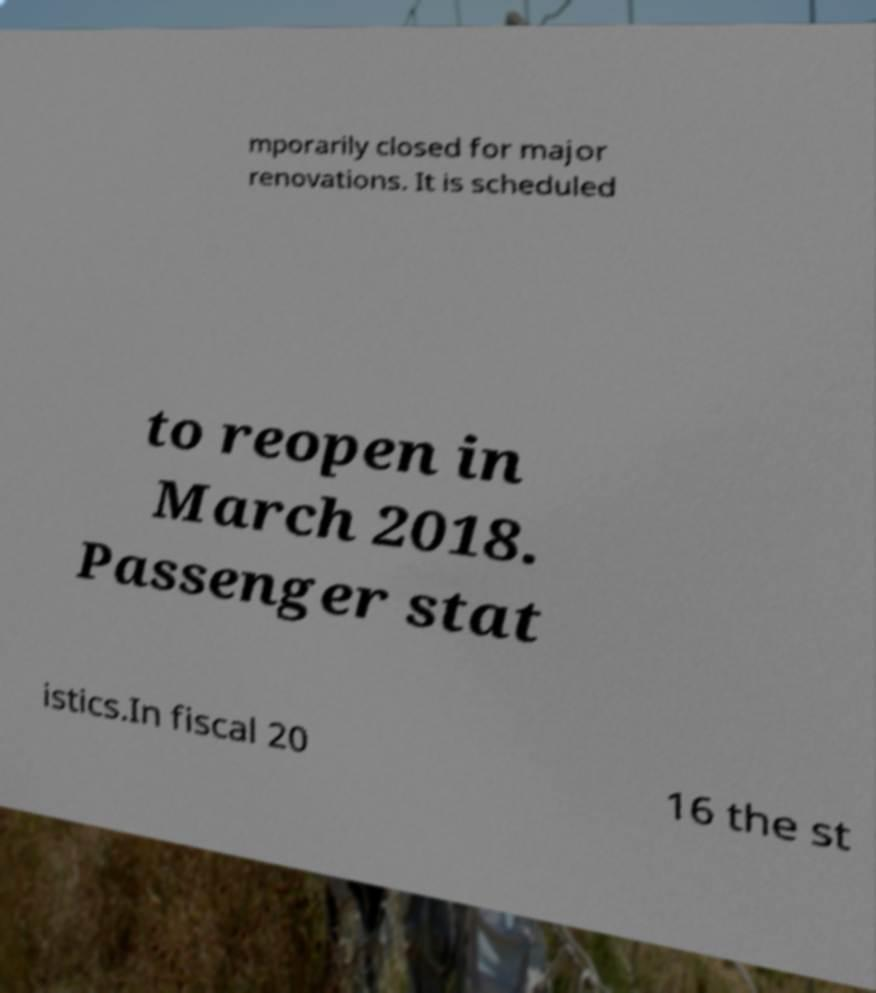Could you extract and type out the text from this image? mporarily closed for major renovations. It is scheduled to reopen in March 2018. Passenger stat istics.In fiscal 20 16 the st 